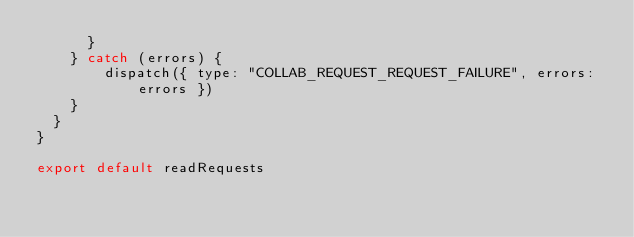Convert code to text. <code><loc_0><loc_0><loc_500><loc_500><_JavaScript_>      }
    } catch (errors) {
        dispatch({ type: "COLLAB_REQUEST_REQUEST_FAILURE", errors: errors })
    }
  }
}

export default readRequests</code> 